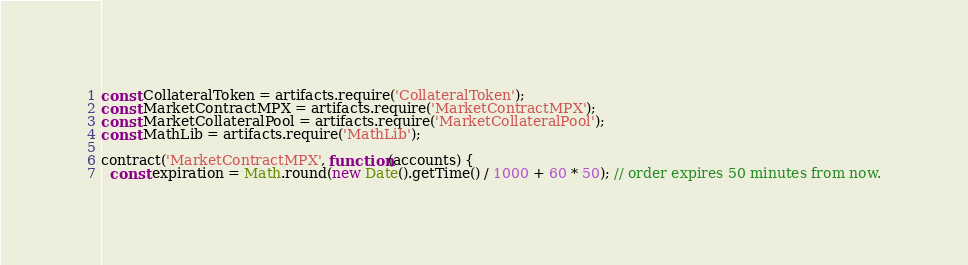Convert code to text. <code><loc_0><loc_0><loc_500><loc_500><_JavaScript_>const CollateralToken = artifacts.require('CollateralToken');
const MarketContractMPX = artifacts.require('MarketContractMPX');
const MarketCollateralPool = artifacts.require('MarketCollateralPool');
const MathLib = artifacts.require('MathLib');

contract('MarketContractMPX', function(accounts) {
  const expiration = Math.round(new Date().getTime() / 1000 + 60 * 50); // order expires 50 minutes from now.</code> 